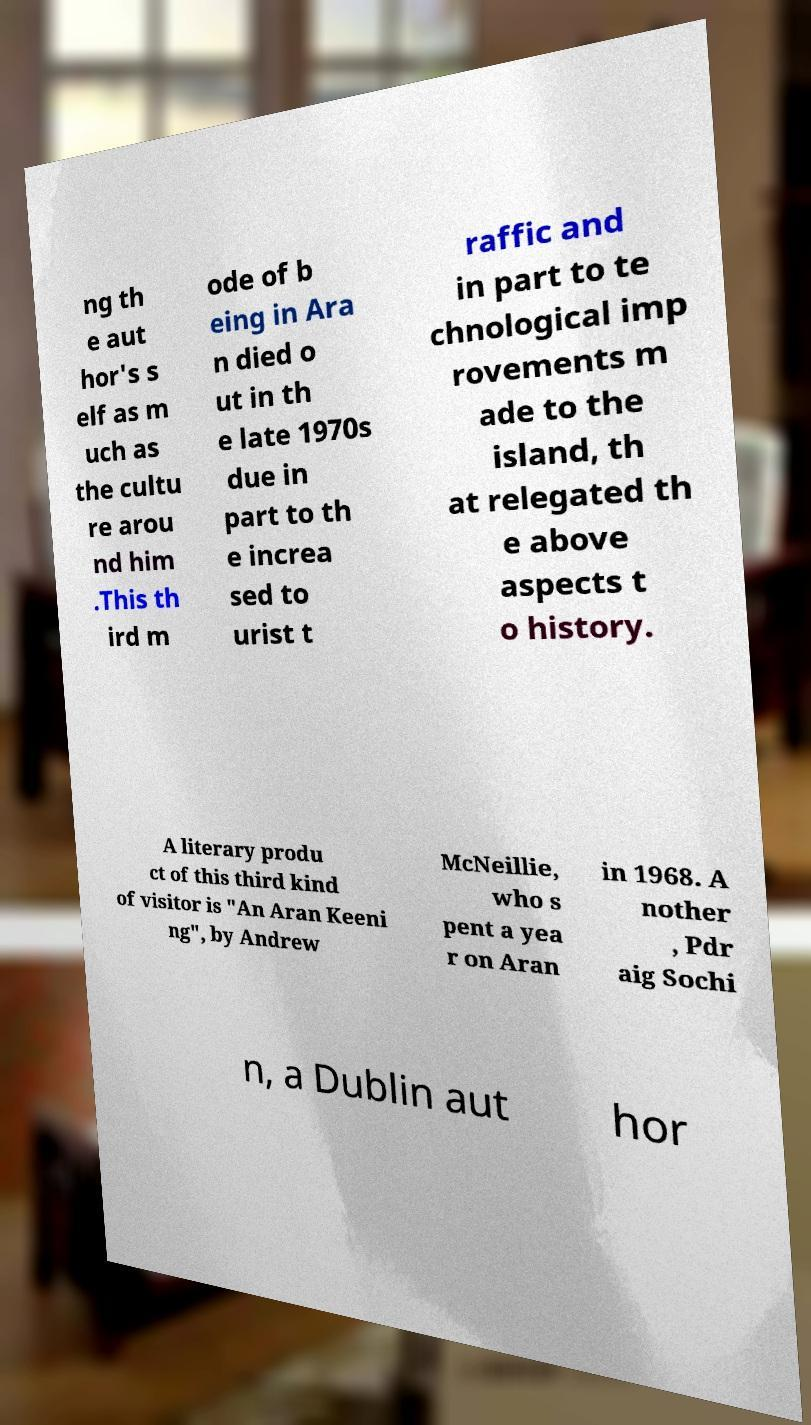I need the written content from this picture converted into text. Can you do that? ng th e aut hor's s elf as m uch as the cultu re arou nd him .This th ird m ode of b eing in Ara n died o ut in th e late 1970s due in part to th e increa sed to urist t raffic and in part to te chnological imp rovements m ade to the island, th at relegated th e above aspects t o history. A literary produ ct of this third kind of visitor is "An Aran Keeni ng", by Andrew McNeillie, who s pent a yea r on Aran in 1968. A nother , Pdr aig Sochi n, a Dublin aut hor 